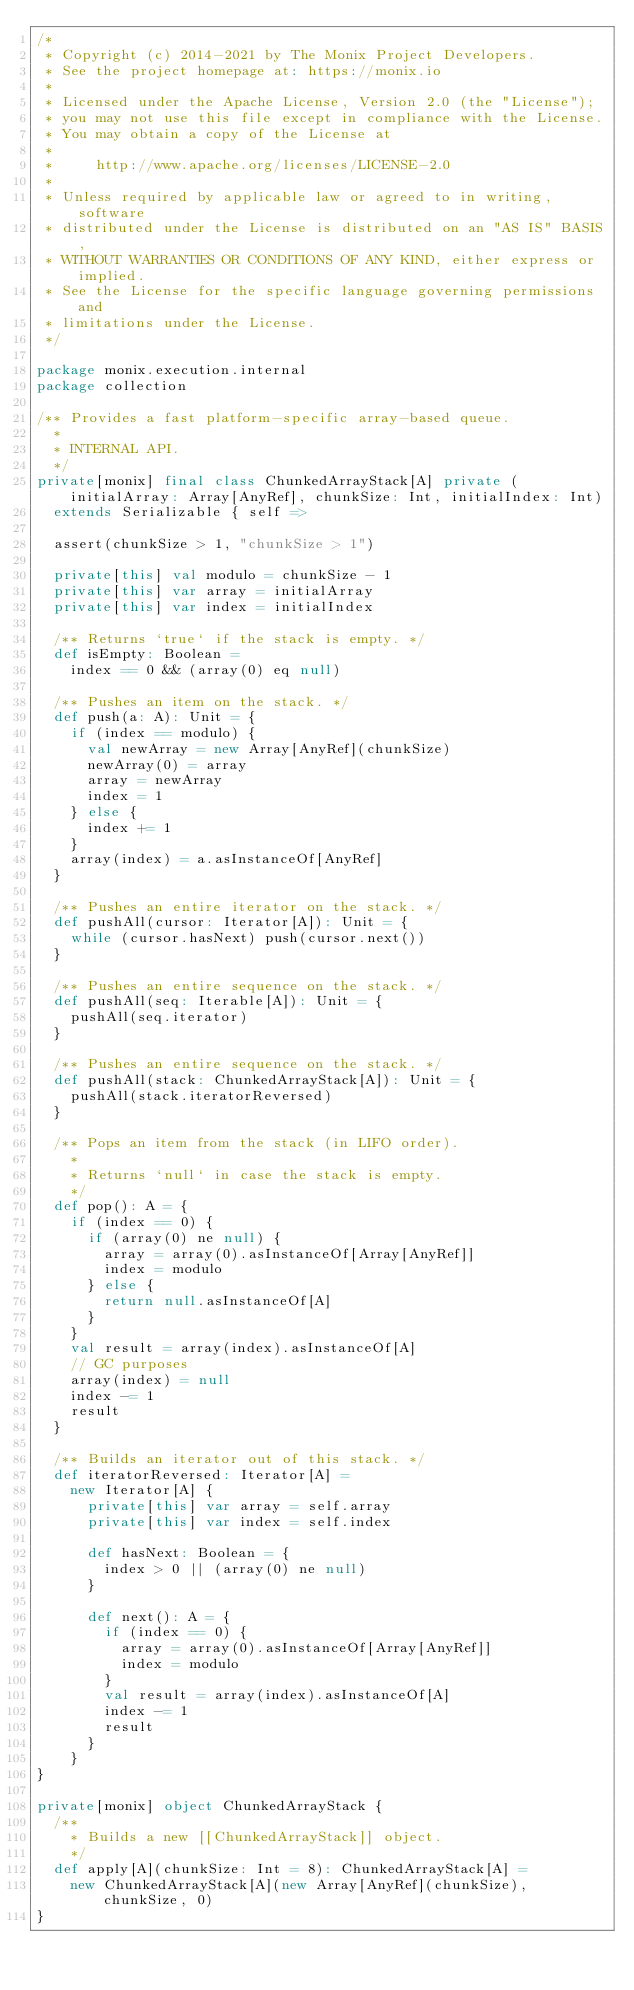Convert code to text. <code><loc_0><loc_0><loc_500><loc_500><_Scala_>/*
 * Copyright (c) 2014-2021 by The Monix Project Developers.
 * See the project homepage at: https://monix.io
 *
 * Licensed under the Apache License, Version 2.0 (the "License");
 * you may not use this file except in compliance with the License.
 * You may obtain a copy of the License at
 *
 *     http://www.apache.org/licenses/LICENSE-2.0
 *
 * Unless required by applicable law or agreed to in writing, software
 * distributed under the License is distributed on an "AS IS" BASIS,
 * WITHOUT WARRANTIES OR CONDITIONS OF ANY KIND, either express or implied.
 * See the License for the specific language governing permissions and
 * limitations under the License.
 */

package monix.execution.internal
package collection

/** Provides a fast platform-specific array-based queue.
  *
  * INTERNAL API.
  */
private[monix] final class ChunkedArrayStack[A] private (initialArray: Array[AnyRef], chunkSize: Int, initialIndex: Int)
  extends Serializable { self =>

  assert(chunkSize > 1, "chunkSize > 1")

  private[this] val modulo = chunkSize - 1
  private[this] var array = initialArray
  private[this] var index = initialIndex

  /** Returns `true` if the stack is empty. */
  def isEmpty: Boolean =
    index == 0 && (array(0) eq null)

  /** Pushes an item on the stack. */
  def push(a: A): Unit = {
    if (index == modulo) {
      val newArray = new Array[AnyRef](chunkSize)
      newArray(0) = array
      array = newArray
      index = 1
    } else {
      index += 1
    }
    array(index) = a.asInstanceOf[AnyRef]
  }

  /** Pushes an entire iterator on the stack. */
  def pushAll(cursor: Iterator[A]): Unit = {
    while (cursor.hasNext) push(cursor.next())
  }

  /** Pushes an entire sequence on the stack. */
  def pushAll(seq: Iterable[A]): Unit = {
    pushAll(seq.iterator)
  }

  /** Pushes an entire sequence on the stack. */
  def pushAll(stack: ChunkedArrayStack[A]): Unit = {
    pushAll(stack.iteratorReversed)
  }

  /** Pops an item from the stack (in LIFO order).
    *
    * Returns `null` in case the stack is empty.
    */
  def pop(): A = {
    if (index == 0) {
      if (array(0) ne null) {
        array = array(0).asInstanceOf[Array[AnyRef]]
        index = modulo
      } else {
        return null.asInstanceOf[A]
      }
    }
    val result = array(index).asInstanceOf[A]
    // GC purposes
    array(index) = null
    index -= 1
    result
  }

  /** Builds an iterator out of this stack. */
  def iteratorReversed: Iterator[A] =
    new Iterator[A] {
      private[this] var array = self.array
      private[this] var index = self.index

      def hasNext: Boolean = {
        index > 0 || (array(0) ne null)
      }

      def next(): A = {
        if (index == 0) {
          array = array(0).asInstanceOf[Array[AnyRef]]
          index = modulo
        }
        val result = array(index).asInstanceOf[A]
        index -= 1
        result
      }
    }
}

private[monix] object ChunkedArrayStack {
  /**
    * Builds a new [[ChunkedArrayStack]] object.
    */
  def apply[A](chunkSize: Int = 8): ChunkedArrayStack[A] =
    new ChunkedArrayStack[A](new Array[AnyRef](chunkSize), chunkSize, 0)
}
</code> 